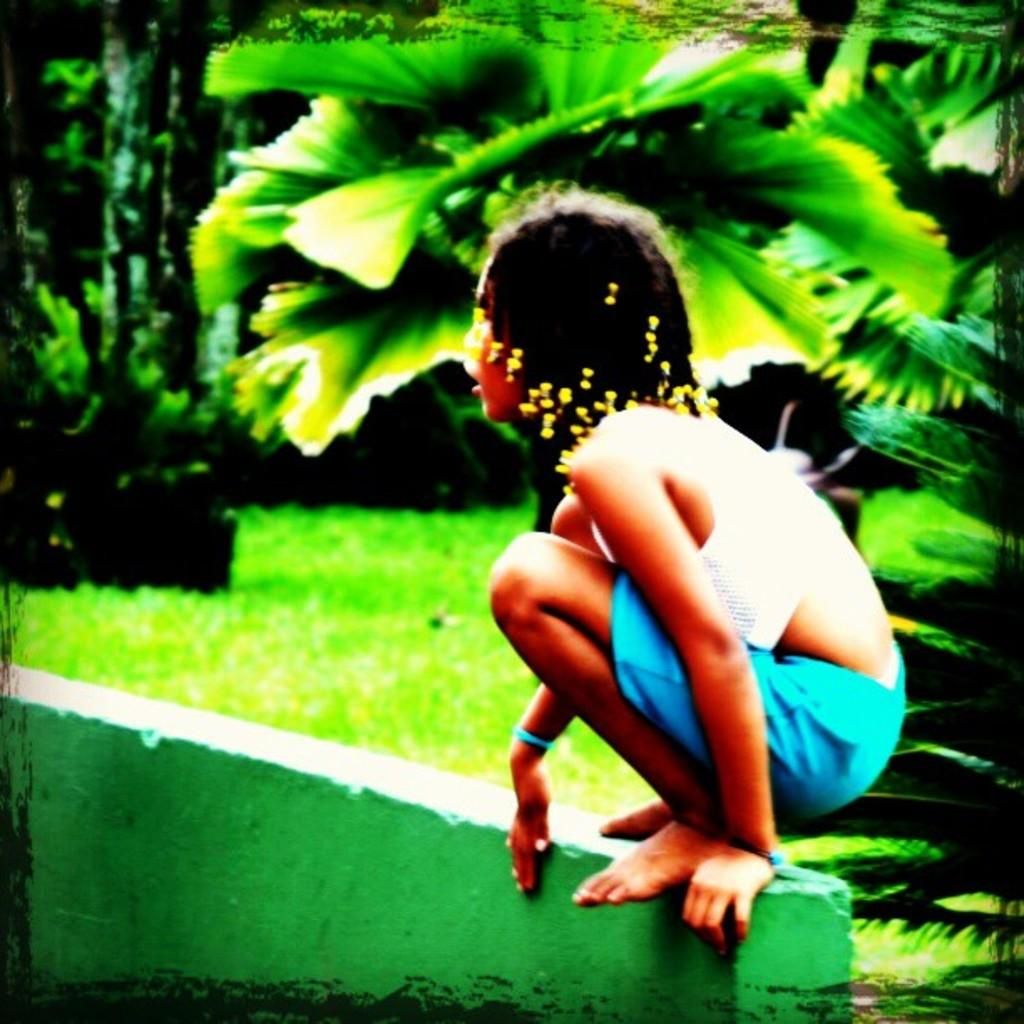Who is the main subject in the image? There is a girl in the image. What is the girl doing in the image? The girl is sitting in a squat position on a wall. What can be seen in the background of the image? There are trees and grass in the background of the image. What type of gun is the girl holding in the image? There is no gun present in the image; the girl is simply sitting on a wall. 